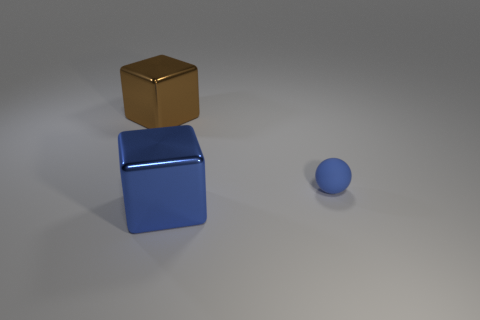Add 1 big green shiny cubes. How many objects exist? 4 Subtract all spheres. How many objects are left? 2 Subtract all tiny blue rubber balls. Subtract all balls. How many objects are left? 1 Add 1 matte spheres. How many matte spheres are left? 2 Add 2 metal blocks. How many metal blocks exist? 4 Subtract 0 yellow spheres. How many objects are left? 3 